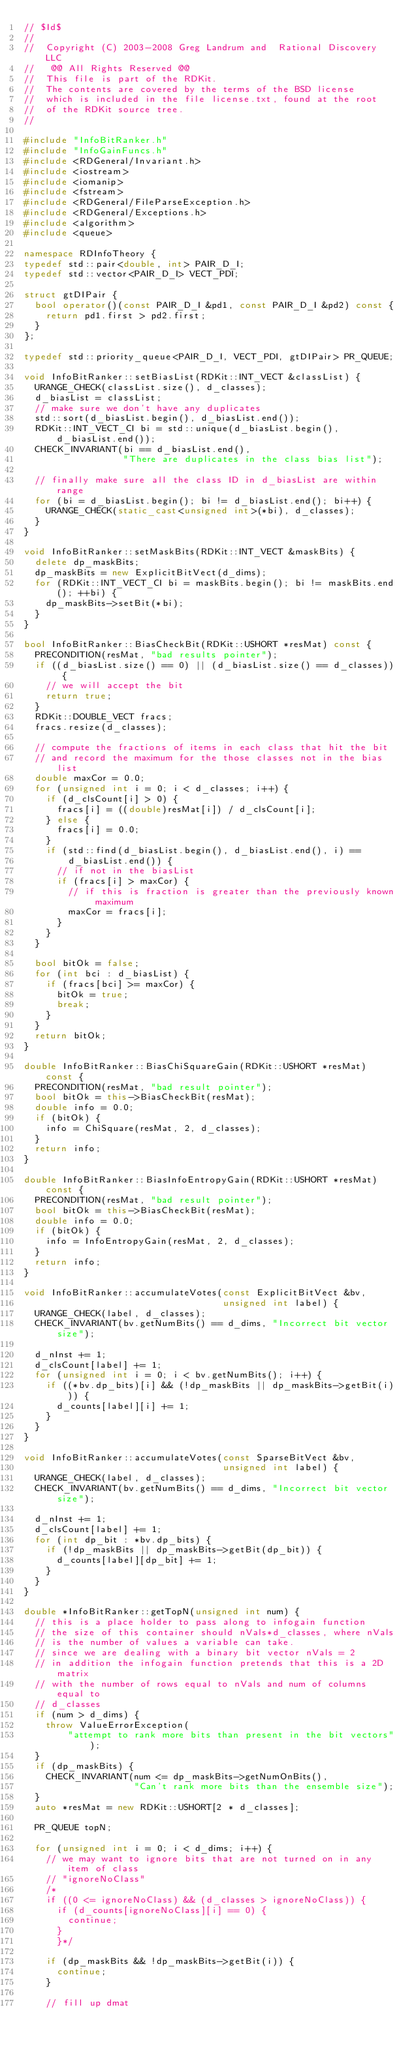<code> <loc_0><loc_0><loc_500><loc_500><_C++_>// $Id$
//
//  Copyright (C) 2003-2008 Greg Landrum and  Rational Discovery LLC
//   @@ All Rights Reserved @@
//  This file is part of the RDKit.
//  The contents are covered by the terms of the BSD license
//  which is included in the file license.txt, found at the root
//  of the RDKit source tree.
//

#include "InfoBitRanker.h"
#include "InfoGainFuncs.h"
#include <RDGeneral/Invariant.h>
#include <iostream>
#include <iomanip>
#include <fstream>
#include <RDGeneral/FileParseException.h>
#include <RDGeneral/Exceptions.h>
#include <algorithm>
#include <queue>

namespace RDInfoTheory {
typedef std::pair<double, int> PAIR_D_I;
typedef std::vector<PAIR_D_I> VECT_PDI;

struct gtDIPair {
  bool operator()(const PAIR_D_I &pd1, const PAIR_D_I &pd2) const {
    return pd1.first > pd2.first;
  }
};

typedef std::priority_queue<PAIR_D_I, VECT_PDI, gtDIPair> PR_QUEUE;

void InfoBitRanker::setBiasList(RDKit::INT_VECT &classList) {
  URANGE_CHECK(classList.size(), d_classes);
  d_biasList = classList;
  // make sure we don't have any duplicates
  std::sort(d_biasList.begin(), d_biasList.end());
  RDKit::INT_VECT_CI bi = std::unique(d_biasList.begin(), d_biasList.end());
  CHECK_INVARIANT(bi == d_biasList.end(),
                  "There are duplicates in the class bias list");

  // finally make sure all the class ID in d_biasList are within range
  for (bi = d_biasList.begin(); bi != d_biasList.end(); bi++) {
    URANGE_CHECK(static_cast<unsigned int>(*bi), d_classes);
  }
}

void InfoBitRanker::setMaskBits(RDKit::INT_VECT &maskBits) {
  delete dp_maskBits;
  dp_maskBits = new ExplicitBitVect(d_dims);
  for (RDKit::INT_VECT_CI bi = maskBits.begin(); bi != maskBits.end(); ++bi) {
    dp_maskBits->setBit(*bi);
  }
}

bool InfoBitRanker::BiasCheckBit(RDKit::USHORT *resMat) const {
  PRECONDITION(resMat, "bad results pointer");
  if ((d_biasList.size() == 0) || (d_biasList.size() == d_classes)) {
    // we will accept the bit
    return true;
  }
  RDKit::DOUBLE_VECT fracs;
  fracs.resize(d_classes);

  // compute the fractions of items in each class that hit the bit
  // and record the maximum for the those classes not in the bias list
  double maxCor = 0.0;
  for (unsigned int i = 0; i < d_classes; i++) {
    if (d_clsCount[i] > 0) {
      fracs[i] = ((double)resMat[i]) / d_clsCount[i];
    } else {
      fracs[i] = 0.0;
    }
    if (std::find(d_biasList.begin(), d_biasList.end(), i) ==
        d_biasList.end()) {
      // if not in the biasList
      if (fracs[i] > maxCor) {
        // if this is fraction is greater than the previously known maximum
        maxCor = fracs[i];
      }
    }
  }

  bool bitOk = false;
  for (int bci : d_biasList) {
    if (fracs[bci] >= maxCor) {
      bitOk = true;
      break;
    }
  }
  return bitOk;
}

double InfoBitRanker::BiasChiSquareGain(RDKit::USHORT *resMat) const {
  PRECONDITION(resMat, "bad result pointer");
  bool bitOk = this->BiasCheckBit(resMat);
  double info = 0.0;
  if (bitOk) {
    info = ChiSquare(resMat, 2, d_classes);
  }
  return info;
}

double InfoBitRanker::BiasInfoEntropyGain(RDKit::USHORT *resMat) const {
  PRECONDITION(resMat, "bad result pointer");
  bool bitOk = this->BiasCheckBit(resMat);
  double info = 0.0;
  if (bitOk) {
    info = InfoEntropyGain(resMat, 2, d_classes);
  }
  return info;
}

void InfoBitRanker::accumulateVotes(const ExplicitBitVect &bv,
                                    unsigned int label) {
  URANGE_CHECK(label, d_classes);
  CHECK_INVARIANT(bv.getNumBits() == d_dims, "Incorrect bit vector size");

  d_nInst += 1;
  d_clsCount[label] += 1;
  for (unsigned int i = 0; i < bv.getNumBits(); i++) {
    if ((*bv.dp_bits)[i] && (!dp_maskBits || dp_maskBits->getBit(i))) {
      d_counts[label][i] += 1;
    }
  }
}

void InfoBitRanker::accumulateVotes(const SparseBitVect &bv,
                                    unsigned int label) {
  URANGE_CHECK(label, d_classes);
  CHECK_INVARIANT(bv.getNumBits() == d_dims, "Incorrect bit vector size");

  d_nInst += 1;
  d_clsCount[label] += 1;
  for (int dp_bit : *bv.dp_bits) {
    if (!dp_maskBits || dp_maskBits->getBit(dp_bit)) {
      d_counts[label][dp_bit] += 1;
    }
  }
}

double *InfoBitRanker::getTopN(unsigned int num) {
  // this is a place holder to pass along to infogain function
  // the size of this container should nVals*d_classes, where nVals
  // is the number of values a variable can take.
  // since we are dealing with a binary bit vector nVals = 2
  // in addition the infogain function pretends that this is a 2D matrix
  // with the number of rows equal to nVals and num of columns equal to
  // d_classes
  if (num > d_dims) {
    throw ValueErrorException(
        "attempt to rank more bits than present in the bit vectors");
  }
  if (dp_maskBits) {
    CHECK_INVARIANT(num <= dp_maskBits->getNumOnBits(),
                    "Can't rank more bits than the ensemble size");
  }
  auto *resMat = new RDKit::USHORT[2 * d_classes];

  PR_QUEUE topN;

  for (unsigned int i = 0; i < d_dims; i++) {
    // we may want to ignore bits that are not turned on in any item of class
    // "ignoreNoClass"
    /*
    if ((0 <= ignoreNoClass) && (d_classes > ignoreNoClass)) {
      if (d_counts[ignoreNoClass][i] == 0) {
        continue;
      }
      }*/

    if (dp_maskBits && !dp_maskBits->getBit(i)) {
      continue;
    }

    // fill up dmat</code> 